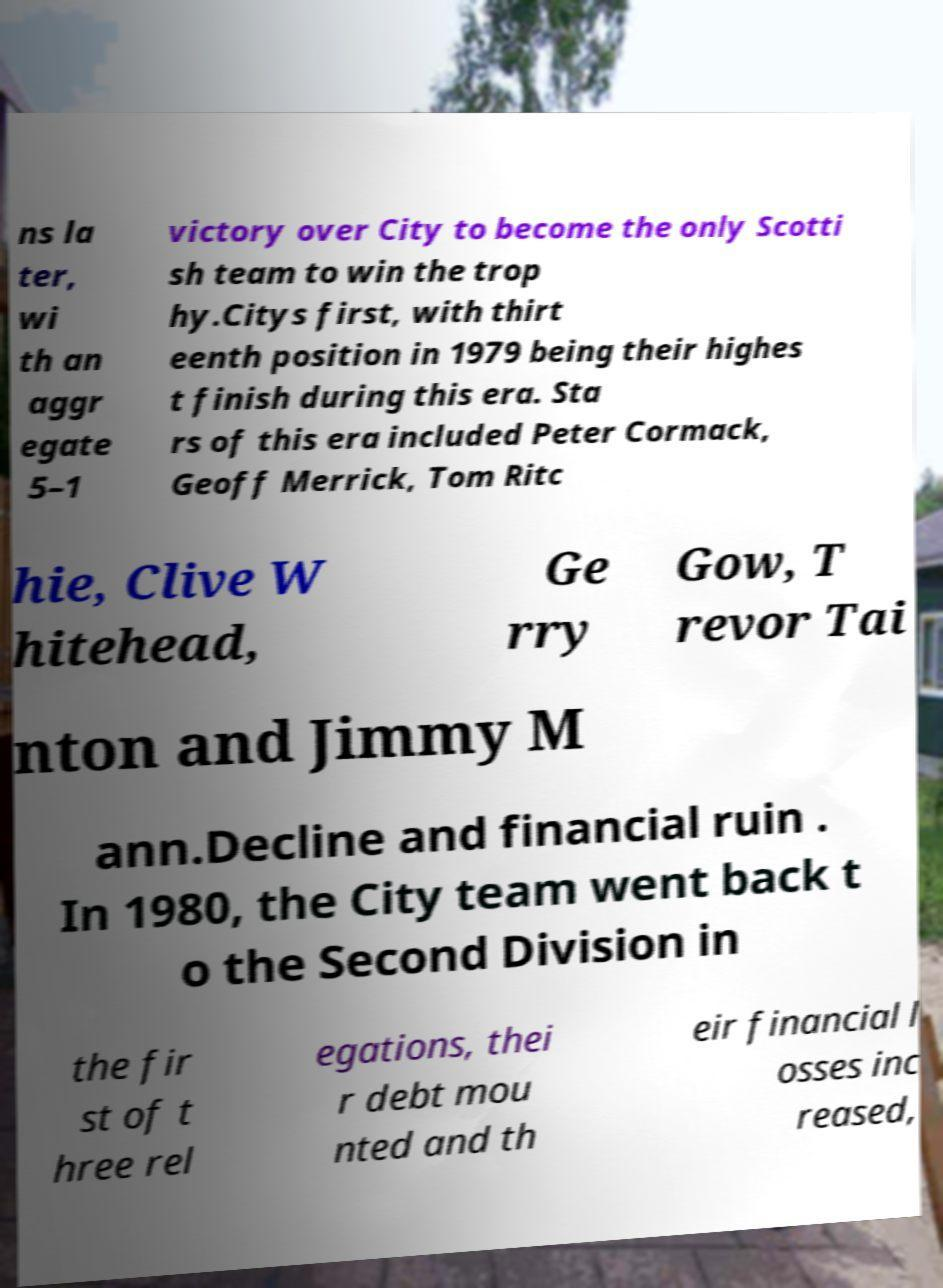Could you assist in decoding the text presented in this image and type it out clearly? ns la ter, wi th an aggr egate 5–1 victory over City to become the only Scotti sh team to win the trop hy.Citys first, with thirt eenth position in 1979 being their highes t finish during this era. Sta rs of this era included Peter Cormack, Geoff Merrick, Tom Ritc hie, Clive W hitehead, Ge rry Gow, T revor Tai nton and Jimmy M ann.Decline and financial ruin . In 1980, the City team went back t o the Second Division in the fir st of t hree rel egations, thei r debt mou nted and th eir financial l osses inc reased, 